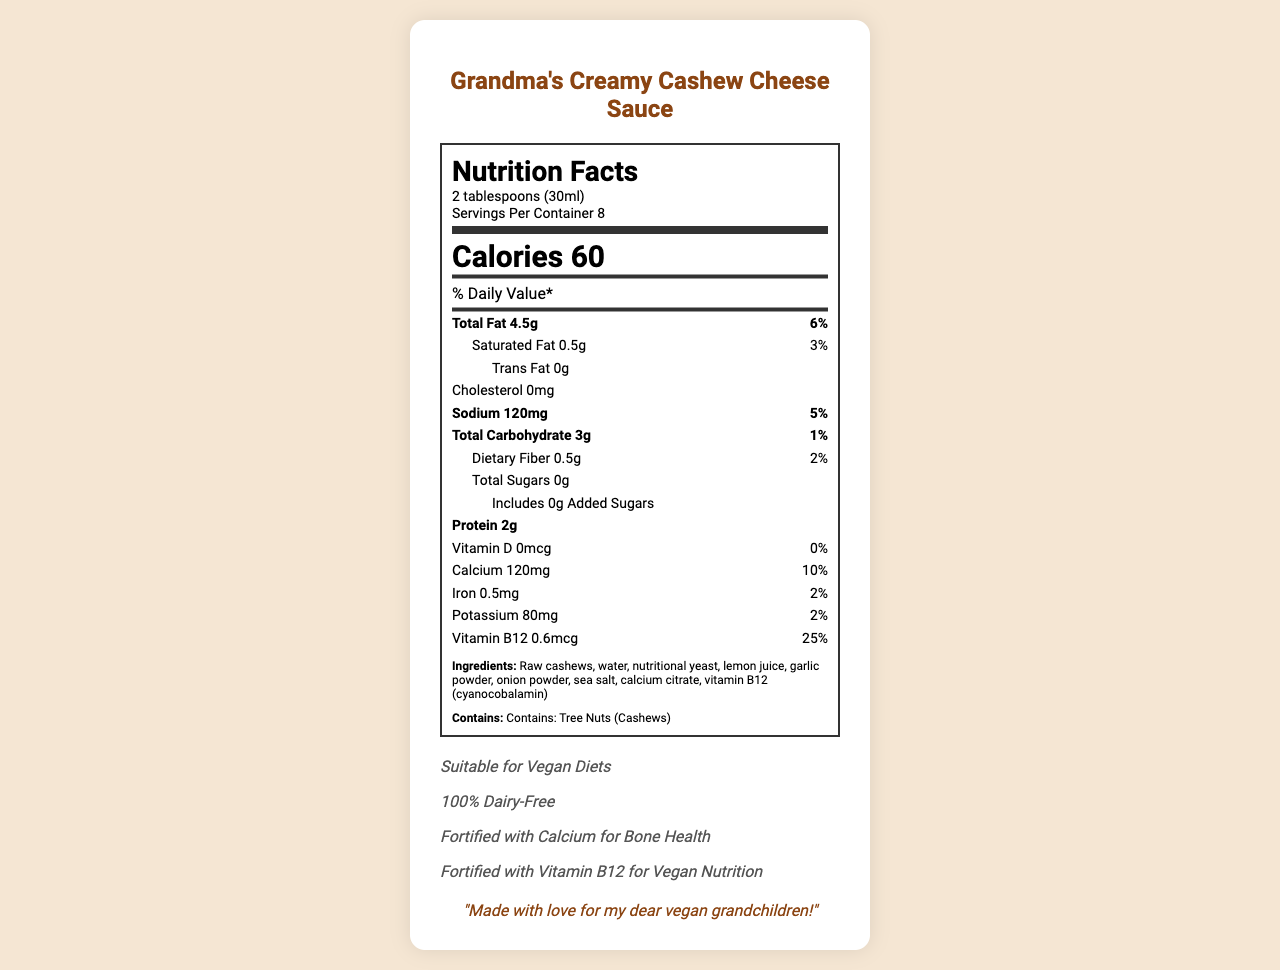what is the serving size for Grandma's Creamy Cashew Cheese Sauce? The serving size is listed near the top of the Nutrition Facts label under the nutrition header.
Answer: 2 tablespoons (30ml) how many calories are in one serving? The label shows that each serving contains 60 calories.
Answer: 60 how many grams of protein are in each serving? The amount of protein per serving is noted in the nutrition section as 2g.
Answer: 2g how much sodium does one serving contain? The sodium content per serving is 120mg as specified in the label.
Answer: 120mg how many servings are in each container of Grandma's Creamy Cashew Cheese Sauce? The label indicates that there are 8 servings per container.
Answer: 8 which nutrient has a daily value percentage of 25%? According to the label, Vitamin B12 has a daily value percentage of 25%.
Answer: Vitamin B12 how much calcium is present in one serving? The amount of calcium per serving, as shown on the label, is 120mg.
Answer: 120mg what is the total carbohydrate amount per serving? A. 1g B. 2g C. 3g D. 4g The label specifies the total carbohydrate amount as 3g per serving.
Answer: C. 3g how much dietary fiber does the sauce contain per serving? A. 0.5g B. 1g C. 1.5g D. 2g The dietary fiber content is listed as 0.5g per serving.
Answer: A. 0.5g is the cashew cheese sauce suitable for vegan diets? The claim "Suitable for Vegan Diets" is included in the document, indicating that it is suitable.
Answer: Yes how long can you use the product after opening? The storage instructions clearly state that the product should be used within 5 days after opening.
Answer: 5 days list the main ingredients in Grandma's Creamy Cashew Cheese Sauce. The ingredients are listed under the ingredients section of the label.
Answer: Raw cashews, water, nutritional yeast, lemon juice, garlic powder, onion powder, sea salt, calcium citrate, vitamin B12 (cyanocobalamin) what allergens are present in the cashew cheese sauce? The label specifies that the product contains tree nuts, particularly cashews.
Answer: Tree Nuts (Cashews) is there any cholesterol in this product? The cholesterol amount is listed as 0mg, indicating that there is no cholesterol in the product.
Answer: No who is the cashew cheese sauce made for, according to the document? The grandmother note states that the product is made with love for her dear vegan grandchildren.
Answer: Vegan grandchildren what is the main purpose of this document? The document is a Nutrition Facts label outlining the various nutritional details and claims for Grandma's Creamy Cashew Cheese Sauce.
Answer: To provide nutritional information about Grandma's Creamy Cashew Cheese Sauce, including serving size, ingredient list, allergen information, and nutritional content. how many grams of total sugars are in a serving? The label states that there are 0g of total sugars per serving.
Answer: 0g what is the total fat content per serving? The total fat amount is indicated as 4.5g per serving in the nutrition label.
Answer: 4.5g is the product fortified with vitamin B12, and why is it important for vegan nutrition? The claim "Fortified with Vitamin B12 for Vegan Nutrition" highlights that the product is supplemented with Vitamin B12, which is essential as it is typically found in animal products and may be deficient in vegan diets.
Answer: Yes, because it provides a crucial nutrient often lacking in vegan diets. can the product's preparation tips be found on the document? The document does not include preparation tips.
Answer: No 